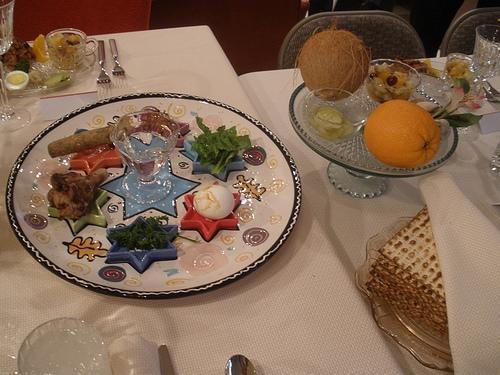How many oranges are in the bowl?
Give a very brief answer. 1. How many bowls are visible?
Give a very brief answer. 2. How many cups can be seen?
Give a very brief answer. 2. How many bottle caps are in the photo?
Give a very brief answer. 0. 